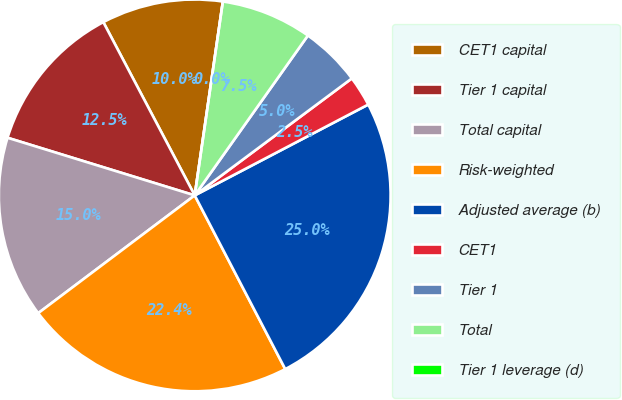Convert chart to OTSL. <chart><loc_0><loc_0><loc_500><loc_500><pie_chart><fcel>CET1 capital<fcel>Tier 1 capital<fcel>Total capital<fcel>Risk-weighted<fcel>Adjusted average (b)<fcel>CET1<fcel>Tier 1<fcel>Total<fcel>Tier 1 leverage (d)<nl><fcel>10.02%<fcel>12.52%<fcel>15.02%<fcel>22.38%<fcel>25.03%<fcel>2.51%<fcel>5.01%<fcel>7.51%<fcel>0.0%<nl></chart> 